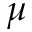<formula> <loc_0><loc_0><loc_500><loc_500>\mu</formula> 